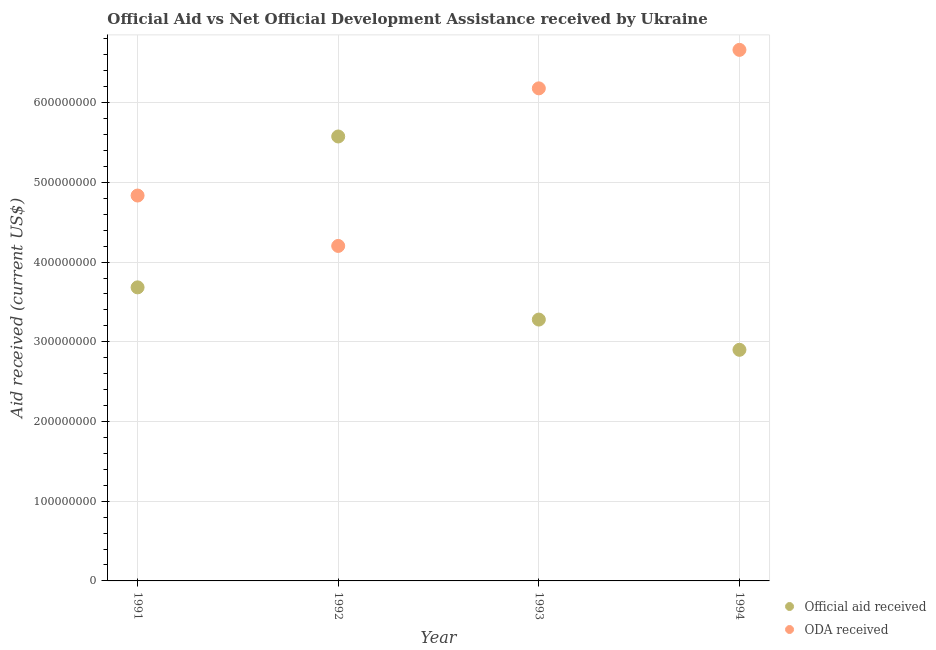What is the oda received in 1991?
Your response must be concise. 4.84e+08. Across all years, what is the maximum official aid received?
Give a very brief answer. 5.58e+08. Across all years, what is the minimum official aid received?
Offer a very short reply. 2.90e+08. In which year was the official aid received minimum?
Ensure brevity in your answer.  1994. What is the total oda received in the graph?
Your answer should be compact. 2.19e+09. What is the difference between the oda received in 1993 and that in 1994?
Give a very brief answer. -4.83e+07. What is the difference between the oda received in 1994 and the official aid received in 1993?
Give a very brief answer. 3.38e+08. What is the average official aid received per year?
Provide a short and direct response. 3.86e+08. In the year 1992, what is the difference between the official aid received and oda received?
Your answer should be very brief. 1.37e+08. What is the ratio of the oda received in 1992 to that in 1994?
Your answer should be compact. 0.63. Is the official aid received in 1993 less than that in 1994?
Ensure brevity in your answer.  No. What is the difference between the highest and the second highest oda received?
Your answer should be very brief. 4.83e+07. What is the difference between the highest and the lowest official aid received?
Your answer should be very brief. 2.68e+08. In how many years, is the official aid received greater than the average official aid received taken over all years?
Keep it short and to the point. 1. Does the oda received monotonically increase over the years?
Ensure brevity in your answer.  No. How many dotlines are there?
Provide a short and direct response. 2. Does the graph contain grids?
Provide a short and direct response. Yes. Where does the legend appear in the graph?
Offer a very short reply. Bottom right. How many legend labels are there?
Give a very brief answer. 2. How are the legend labels stacked?
Your answer should be very brief. Vertical. What is the title of the graph?
Make the answer very short. Official Aid vs Net Official Development Assistance received by Ukraine . Does "Stunting" appear as one of the legend labels in the graph?
Make the answer very short. No. What is the label or title of the Y-axis?
Make the answer very short. Aid received (current US$). What is the Aid received (current US$) in Official aid received in 1991?
Keep it short and to the point. 3.68e+08. What is the Aid received (current US$) of ODA received in 1991?
Your answer should be very brief. 4.84e+08. What is the Aid received (current US$) of Official aid received in 1992?
Keep it short and to the point. 5.58e+08. What is the Aid received (current US$) in ODA received in 1992?
Your response must be concise. 4.20e+08. What is the Aid received (current US$) of Official aid received in 1993?
Offer a very short reply. 3.28e+08. What is the Aid received (current US$) of ODA received in 1993?
Keep it short and to the point. 6.18e+08. What is the Aid received (current US$) of Official aid received in 1994?
Offer a terse response. 2.90e+08. What is the Aid received (current US$) of ODA received in 1994?
Give a very brief answer. 6.66e+08. Across all years, what is the maximum Aid received (current US$) of Official aid received?
Provide a succinct answer. 5.58e+08. Across all years, what is the maximum Aid received (current US$) of ODA received?
Ensure brevity in your answer.  6.66e+08. Across all years, what is the minimum Aid received (current US$) of Official aid received?
Provide a short and direct response. 2.90e+08. Across all years, what is the minimum Aid received (current US$) in ODA received?
Provide a short and direct response. 4.20e+08. What is the total Aid received (current US$) in Official aid received in the graph?
Offer a terse response. 1.54e+09. What is the total Aid received (current US$) of ODA received in the graph?
Provide a succinct answer. 2.19e+09. What is the difference between the Aid received (current US$) of Official aid received in 1991 and that in 1992?
Ensure brevity in your answer.  -1.89e+08. What is the difference between the Aid received (current US$) in ODA received in 1991 and that in 1992?
Ensure brevity in your answer.  6.32e+07. What is the difference between the Aid received (current US$) of Official aid received in 1991 and that in 1993?
Ensure brevity in your answer.  4.04e+07. What is the difference between the Aid received (current US$) in ODA received in 1991 and that in 1993?
Offer a very short reply. -1.34e+08. What is the difference between the Aid received (current US$) of Official aid received in 1991 and that in 1994?
Offer a very short reply. 7.84e+07. What is the difference between the Aid received (current US$) of ODA received in 1991 and that in 1994?
Offer a very short reply. -1.83e+08. What is the difference between the Aid received (current US$) in Official aid received in 1992 and that in 1993?
Keep it short and to the point. 2.30e+08. What is the difference between the Aid received (current US$) in ODA received in 1992 and that in 1993?
Ensure brevity in your answer.  -1.98e+08. What is the difference between the Aid received (current US$) in Official aid received in 1992 and that in 1994?
Offer a terse response. 2.68e+08. What is the difference between the Aid received (current US$) in ODA received in 1992 and that in 1994?
Provide a short and direct response. -2.46e+08. What is the difference between the Aid received (current US$) in Official aid received in 1993 and that in 1994?
Your answer should be very brief. 3.79e+07. What is the difference between the Aid received (current US$) in ODA received in 1993 and that in 1994?
Provide a short and direct response. -4.83e+07. What is the difference between the Aid received (current US$) in Official aid received in 1991 and the Aid received (current US$) in ODA received in 1992?
Make the answer very short. -5.20e+07. What is the difference between the Aid received (current US$) of Official aid received in 1991 and the Aid received (current US$) of ODA received in 1993?
Your answer should be very brief. -2.50e+08. What is the difference between the Aid received (current US$) in Official aid received in 1991 and the Aid received (current US$) in ODA received in 1994?
Your answer should be very brief. -2.98e+08. What is the difference between the Aid received (current US$) of Official aid received in 1992 and the Aid received (current US$) of ODA received in 1993?
Offer a very short reply. -6.04e+07. What is the difference between the Aid received (current US$) in Official aid received in 1992 and the Aid received (current US$) in ODA received in 1994?
Give a very brief answer. -1.09e+08. What is the difference between the Aid received (current US$) of Official aid received in 1993 and the Aid received (current US$) of ODA received in 1994?
Give a very brief answer. -3.38e+08. What is the average Aid received (current US$) in Official aid received per year?
Make the answer very short. 3.86e+08. What is the average Aid received (current US$) in ODA received per year?
Keep it short and to the point. 5.47e+08. In the year 1991, what is the difference between the Aid received (current US$) in Official aid received and Aid received (current US$) in ODA received?
Your answer should be compact. -1.15e+08. In the year 1992, what is the difference between the Aid received (current US$) in Official aid received and Aid received (current US$) in ODA received?
Keep it short and to the point. 1.37e+08. In the year 1993, what is the difference between the Aid received (current US$) of Official aid received and Aid received (current US$) of ODA received?
Keep it short and to the point. -2.90e+08. In the year 1994, what is the difference between the Aid received (current US$) in Official aid received and Aid received (current US$) in ODA received?
Your response must be concise. -3.76e+08. What is the ratio of the Aid received (current US$) in Official aid received in 1991 to that in 1992?
Provide a short and direct response. 0.66. What is the ratio of the Aid received (current US$) of ODA received in 1991 to that in 1992?
Your answer should be very brief. 1.15. What is the ratio of the Aid received (current US$) in Official aid received in 1991 to that in 1993?
Your answer should be compact. 1.12. What is the ratio of the Aid received (current US$) in ODA received in 1991 to that in 1993?
Offer a very short reply. 0.78. What is the ratio of the Aid received (current US$) of Official aid received in 1991 to that in 1994?
Offer a very short reply. 1.27. What is the ratio of the Aid received (current US$) of ODA received in 1991 to that in 1994?
Your response must be concise. 0.73. What is the ratio of the Aid received (current US$) of Official aid received in 1992 to that in 1993?
Give a very brief answer. 1.7. What is the ratio of the Aid received (current US$) in ODA received in 1992 to that in 1993?
Ensure brevity in your answer.  0.68. What is the ratio of the Aid received (current US$) in Official aid received in 1992 to that in 1994?
Your answer should be compact. 1.92. What is the ratio of the Aid received (current US$) of ODA received in 1992 to that in 1994?
Offer a very short reply. 0.63. What is the ratio of the Aid received (current US$) of Official aid received in 1993 to that in 1994?
Provide a short and direct response. 1.13. What is the ratio of the Aid received (current US$) of ODA received in 1993 to that in 1994?
Keep it short and to the point. 0.93. What is the difference between the highest and the second highest Aid received (current US$) in Official aid received?
Give a very brief answer. 1.89e+08. What is the difference between the highest and the second highest Aid received (current US$) of ODA received?
Provide a succinct answer. 4.83e+07. What is the difference between the highest and the lowest Aid received (current US$) of Official aid received?
Offer a terse response. 2.68e+08. What is the difference between the highest and the lowest Aid received (current US$) of ODA received?
Give a very brief answer. 2.46e+08. 